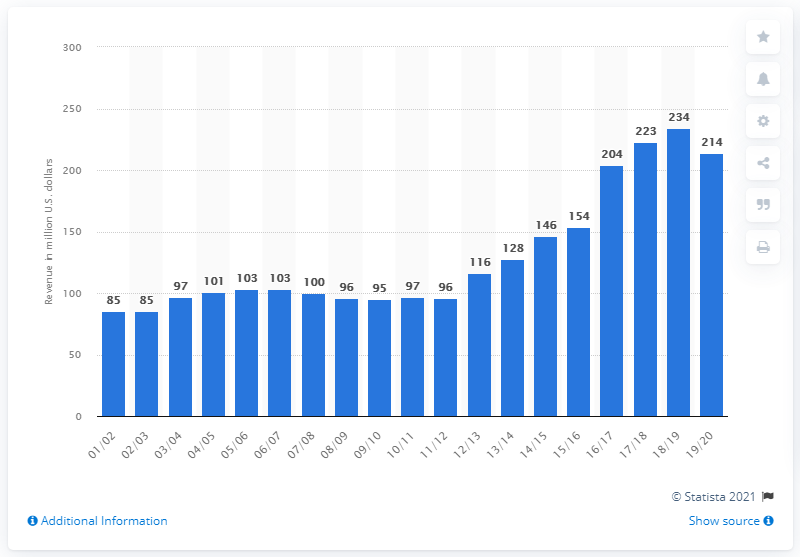List a handful of essential elements in this visual. The estimated revenue of the National Basketball Association in the 2019/2020 fiscal year was 214 billion dollars. 